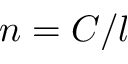<formula> <loc_0><loc_0><loc_500><loc_500>n = C / l</formula> 